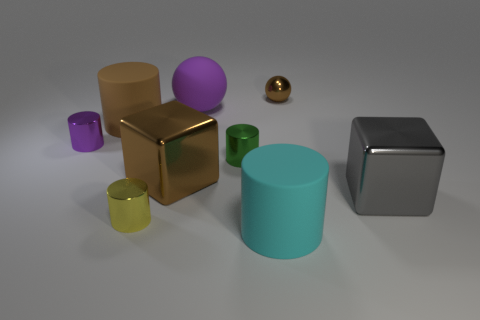Are there any other metallic cylinders of the same size as the yellow metal cylinder?
Provide a succinct answer. Yes. There is a small ball; is it the same color as the large shiny block on the left side of the large cyan cylinder?
Give a very brief answer. Yes. There is a big metal block that is behind the gray object; how many tiny green metallic things are in front of it?
Your answer should be very brief. 0. What is the color of the matte object that is left of the big metallic object on the left side of the large cyan cylinder?
Provide a succinct answer. Brown. What is the material of the big thing that is both on the left side of the big cyan cylinder and in front of the big brown matte object?
Keep it short and to the point. Metal. Are there any purple matte objects of the same shape as the large cyan object?
Offer a very short reply. No. Do the large object that is in front of the gray metallic thing and the big purple rubber object have the same shape?
Make the answer very short. No. What number of metal objects are to the right of the big cyan matte cylinder and to the left of the large brown rubber cylinder?
Your answer should be very brief. 0. There is a brown object that is to the left of the big brown metallic object; what shape is it?
Offer a very short reply. Cylinder. How many small blue objects are made of the same material as the tiny purple cylinder?
Your answer should be very brief. 0. 